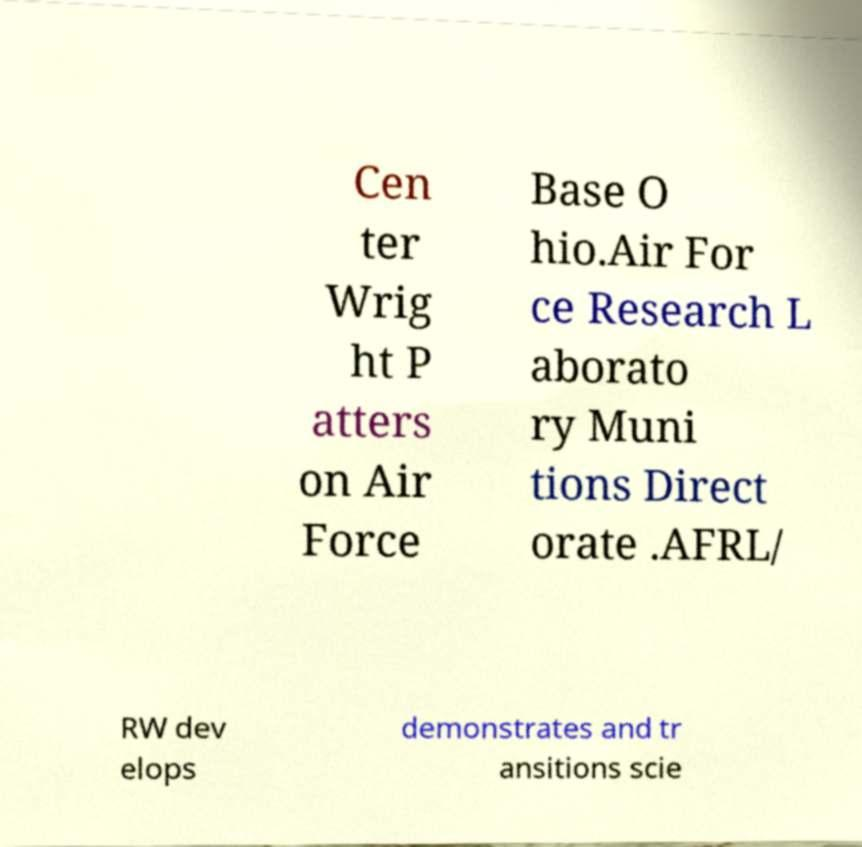I need the written content from this picture converted into text. Can you do that? Cen ter Wrig ht P atters on Air Force Base O hio.Air For ce Research L aborato ry Muni tions Direct orate .AFRL/ RW dev elops demonstrates and tr ansitions scie 